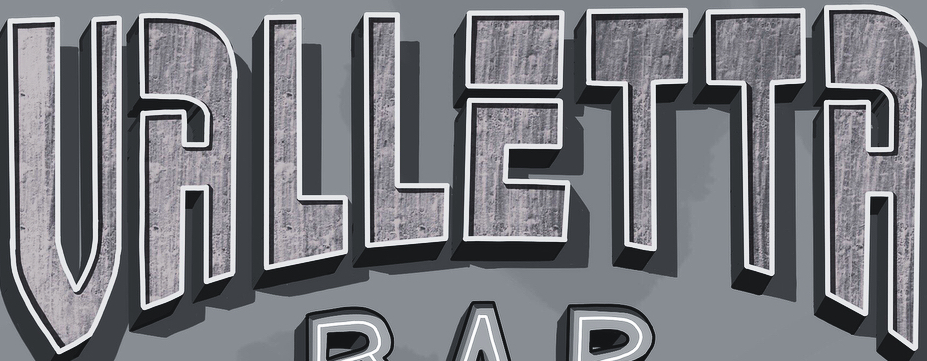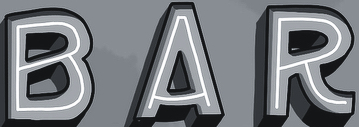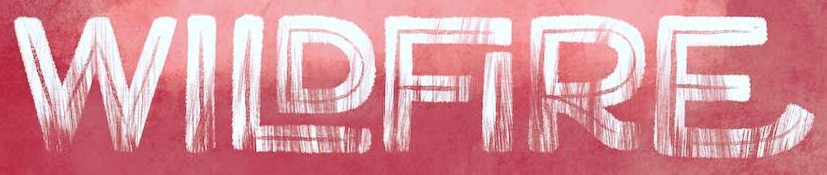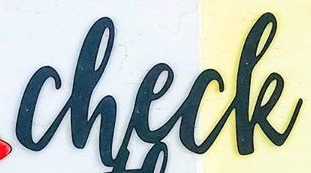Transcribe the words shown in these images in order, separated by a semicolon. VALLETTA; BAR; WILDFIRE; check 